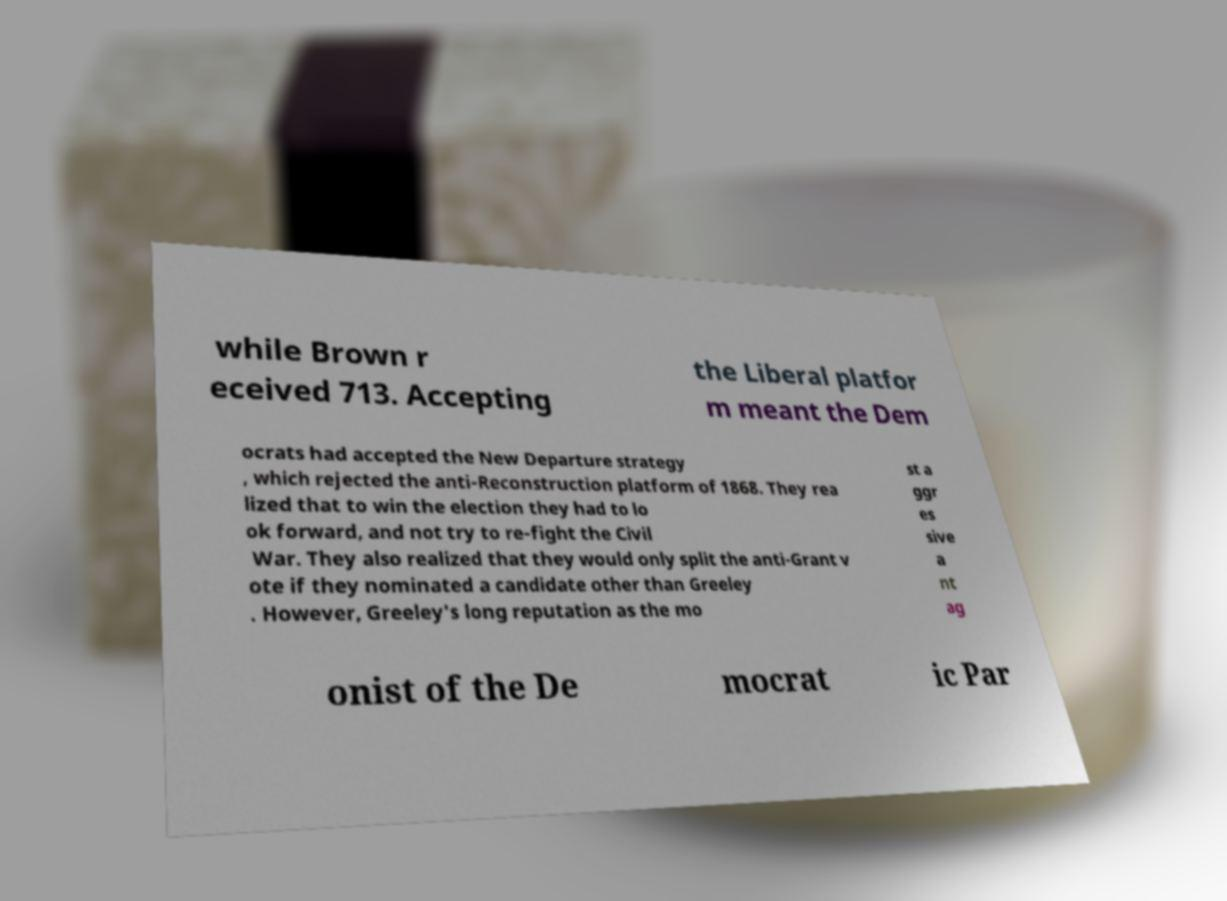For documentation purposes, I need the text within this image transcribed. Could you provide that? while Brown r eceived 713. Accepting the Liberal platfor m meant the Dem ocrats had accepted the New Departure strategy , which rejected the anti-Reconstruction platform of 1868. They rea lized that to win the election they had to lo ok forward, and not try to re-fight the Civil War. They also realized that they would only split the anti-Grant v ote if they nominated a candidate other than Greeley . However, Greeley's long reputation as the mo st a ggr es sive a nt ag onist of the De mocrat ic Par 